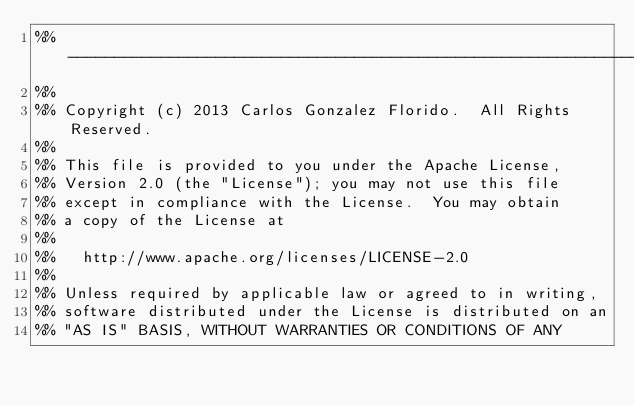<code> <loc_0><loc_0><loc_500><loc_500><_Erlang_>%% -------------------------------------------------------------------
%%
%% Copyright (c) 2013 Carlos Gonzalez Florido.  All Rights Reserved.
%%
%% This file is provided to you under the Apache License,
%% Version 2.0 (the "License"); you may not use this file
%% except in compliance with the License.  You may obtain
%% a copy of the License at
%%
%%   http://www.apache.org/licenses/LICENSE-2.0
%%
%% Unless required by applicable law or agreed to in writing,
%% software distributed under the License is distributed on an
%% "AS IS" BASIS, WITHOUT WARRANTIES OR CONDITIONS OF ANY</code> 